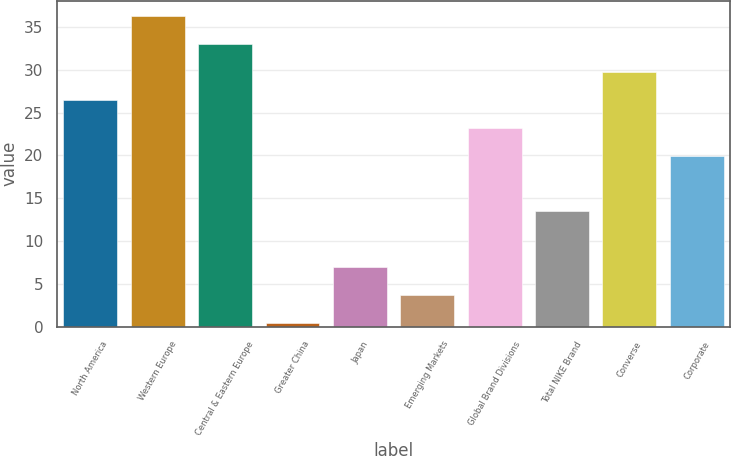<chart> <loc_0><loc_0><loc_500><loc_500><bar_chart><fcel>North America<fcel>Western Europe<fcel>Central & Eastern Europe<fcel>Greater China<fcel>Japan<fcel>Emerging Markets<fcel>Global Brand Divisions<fcel>Total NIKE Brand<fcel>Converse<fcel>Corporate<nl><fcel>26.49<fcel>36.27<fcel>33.01<fcel>0.41<fcel>6.93<fcel>3.67<fcel>23.23<fcel>13.45<fcel>29.75<fcel>19.97<nl></chart> 